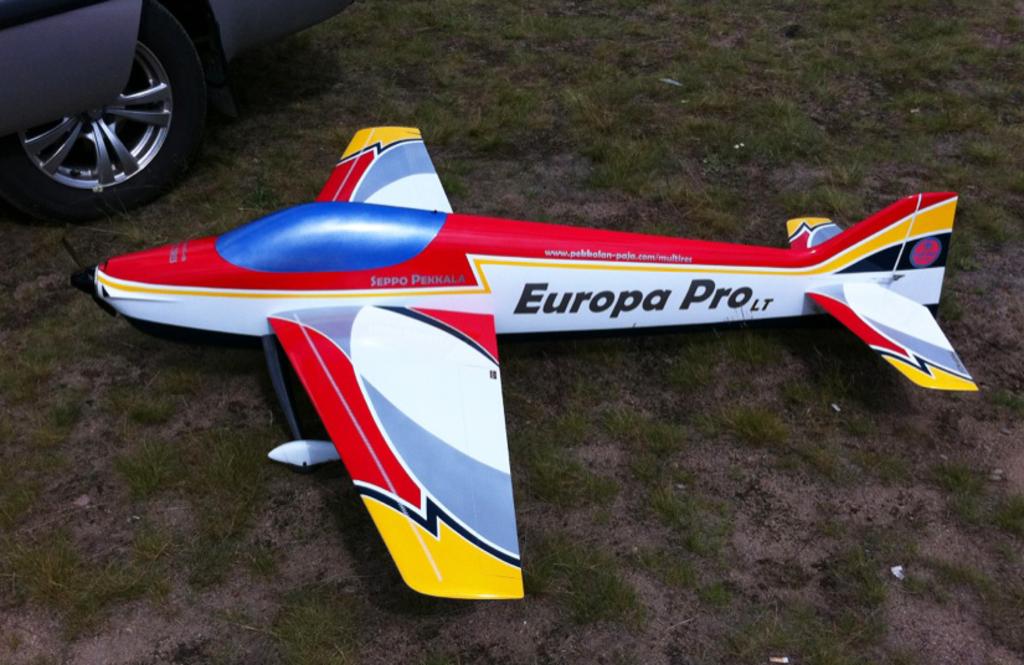What is the brand of this plane/?
Ensure brevity in your answer.  Europa pro lt. 